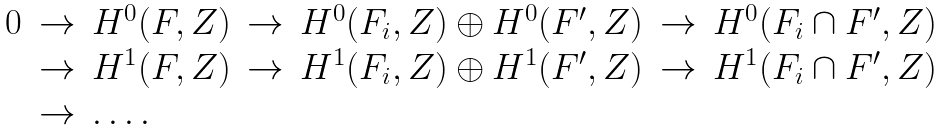<formula> <loc_0><loc_0><loc_500><loc_500>\begin{array} { c c l c l c l } 0 & \rightarrow & H ^ { 0 } ( F , { Z } ) & \rightarrow & H ^ { 0 } ( F _ { i } , { Z } ) \oplus H ^ { 0 } ( F ^ { \prime } , { Z } ) & \rightarrow & H ^ { 0 } ( F _ { i } \cap F ^ { \prime } , { Z } ) \\ & \rightarrow & H ^ { 1 } ( F , { Z } ) & \rightarrow & H ^ { 1 } ( F _ { i } , { Z } ) \oplus H ^ { 1 } ( F ^ { \prime } , { Z } ) & \rightarrow & H ^ { 1 } ( F _ { i } \cap F ^ { \prime } , { Z } ) \\ & \rightarrow & \dots . & & & & \end{array}</formula> 